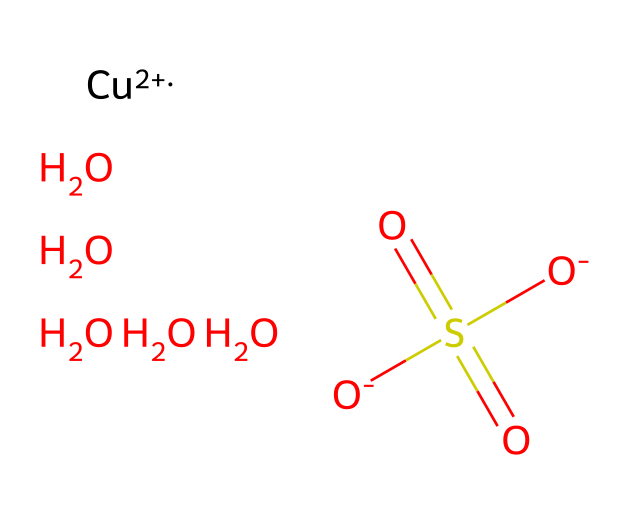What is the central metal atom in this chemical structure? The chemical structure shows [Cu+2], indicating that copper is the central metal atom.
Answer: copper How many oxygen atoms are present in this chemical? By examining the SMILES representation, there are five oxygen atoms represented as [O-] and O.
Answer: five What is the charge of the copper ion in this structure? The structure specifies [Cu+2], indicating that the copper ion carries a +2 charge.
Answer: +2 Which functional groups are present in this chemical? The presence of SO3 and the sulfates (indicated by S(=O)(=O)[O-]) shows that sulfate functional groups are present in the chemical.
Answer: sulfate What is the primary use of this chemical in agriculture? As a fungicide, this chemical is primarily used to prevent and control fungal infections in crops.
Answer: fungicide What type of compound is copper sulfate classified as based on its function? Copper sulfate is classified as an inorganic compound due to its metal and sulfate components, and it functions as a fungicide.
Answer: inorganic compound 